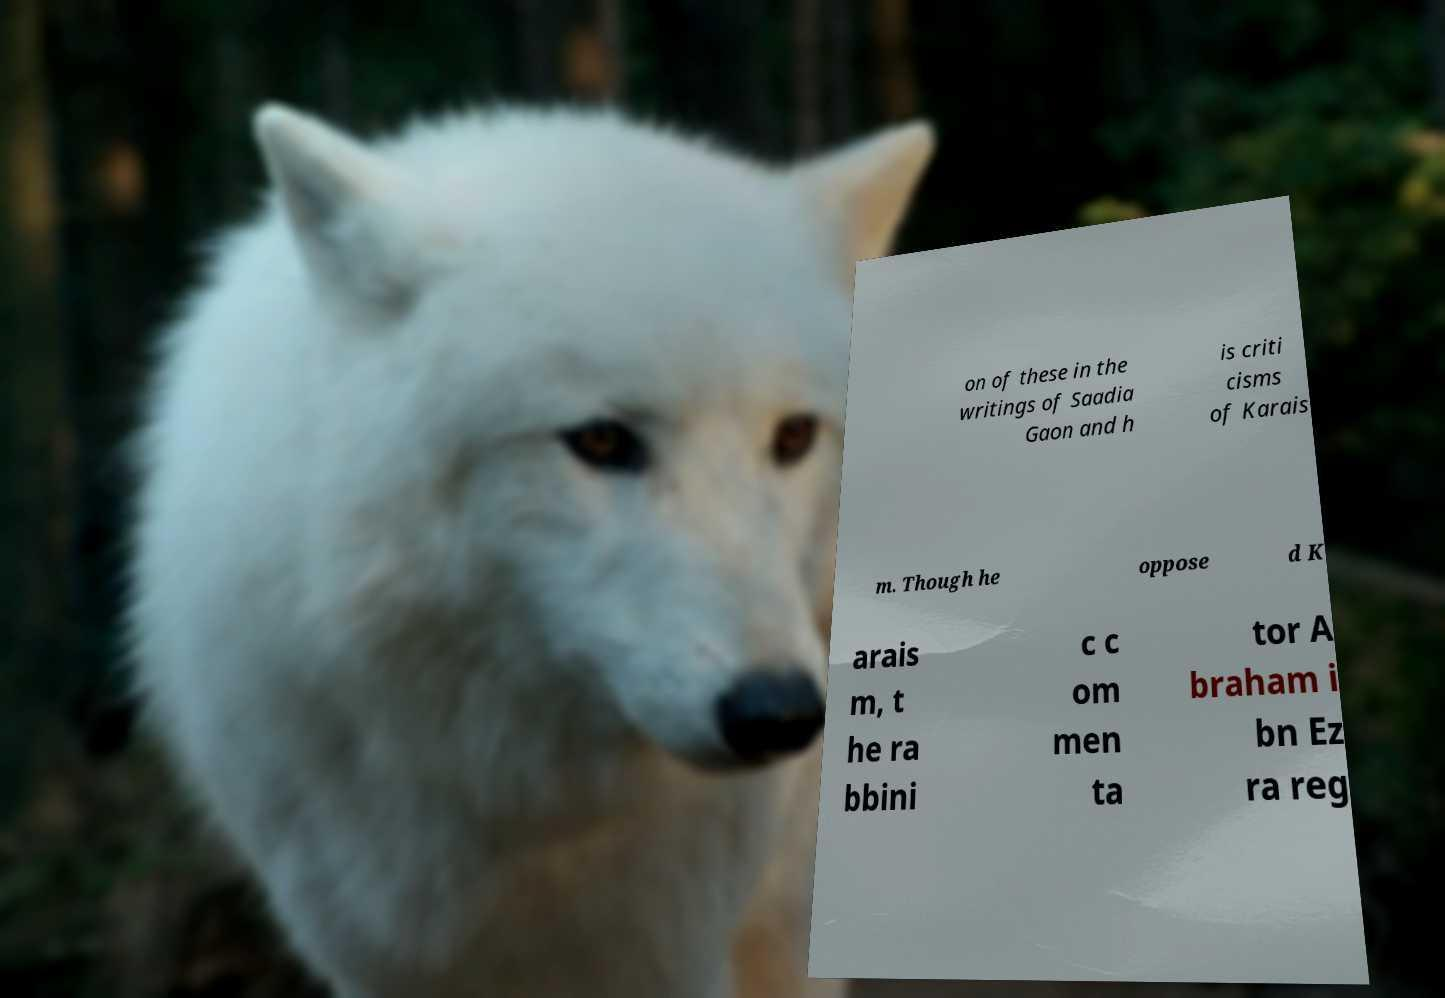Could you assist in decoding the text presented in this image and type it out clearly? on of these in the writings of Saadia Gaon and h is criti cisms of Karais m. Though he oppose d K arais m, t he ra bbini c c om men ta tor A braham i bn Ez ra reg 